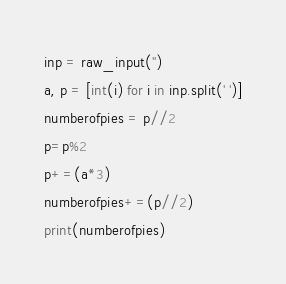<code> <loc_0><loc_0><loc_500><loc_500><_Python_>inp = raw_input('')
a, p = [int(i) for i in inp.split(' ')]
numberofpies = p//2
p=p%2
p+=(a*3)
numberofpies+=(p//2)
print(numberofpies)</code> 